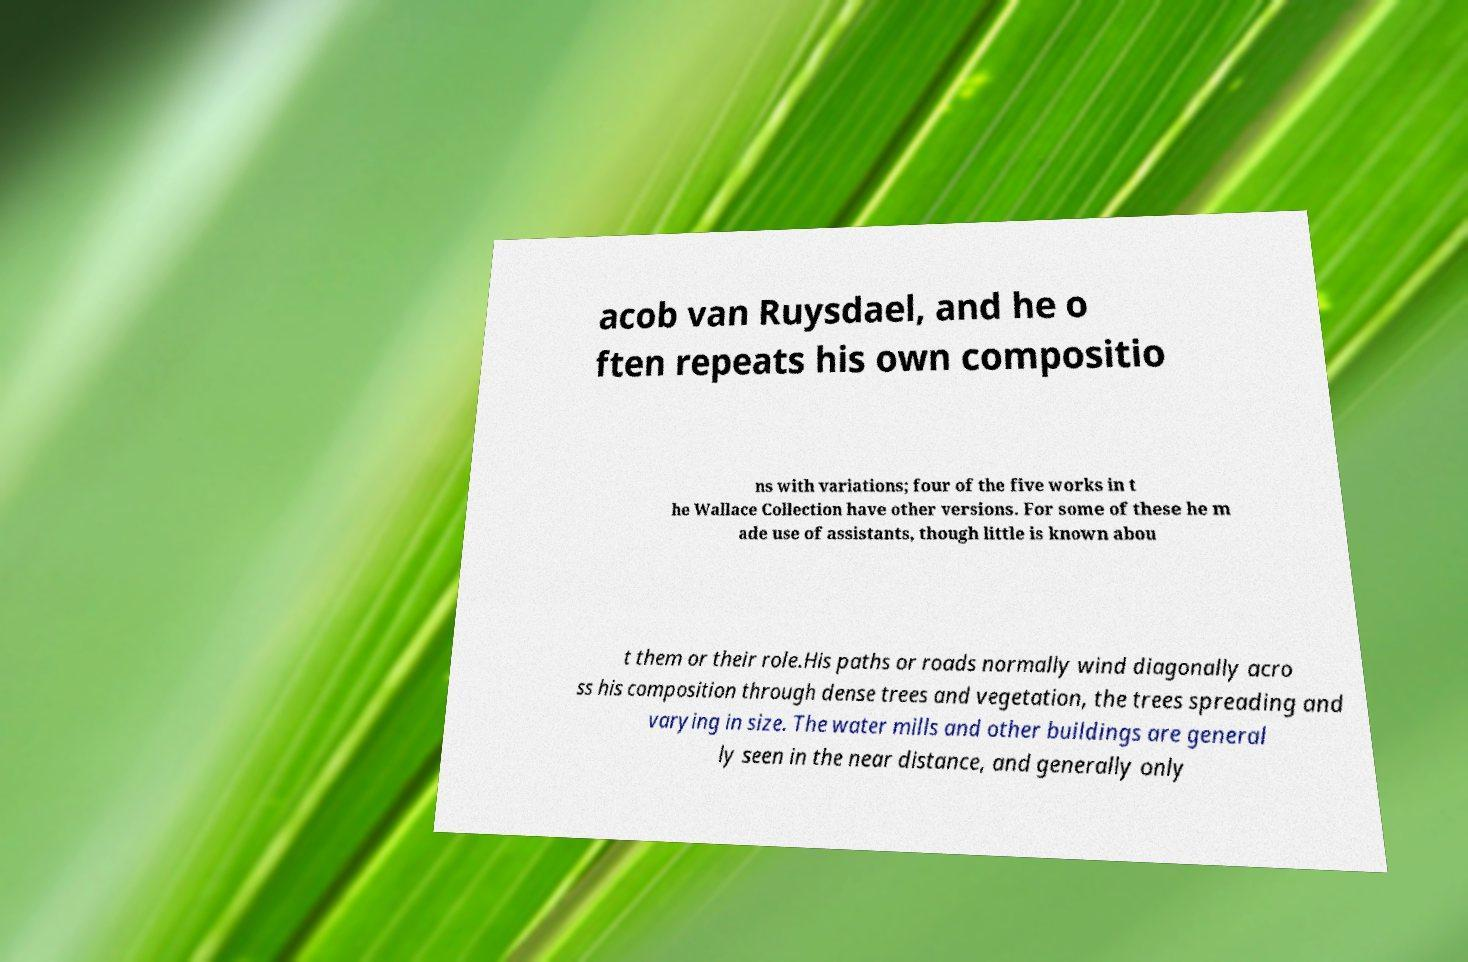I need the written content from this picture converted into text. Can you do that? acob van Ruysdael, and he o ften repeats his own compositio ns with variations; four of the five works in t he Wallace Collection have other versions. For some of these he m ade use of assistants, though little is known abou t them or their role.His paths or roads normally wind diagonally acro ss his composition through dense trees and vegetation, the trees spreading and varying in size. The water mills and other buildings are general ly seen in the near distance, and generally only 